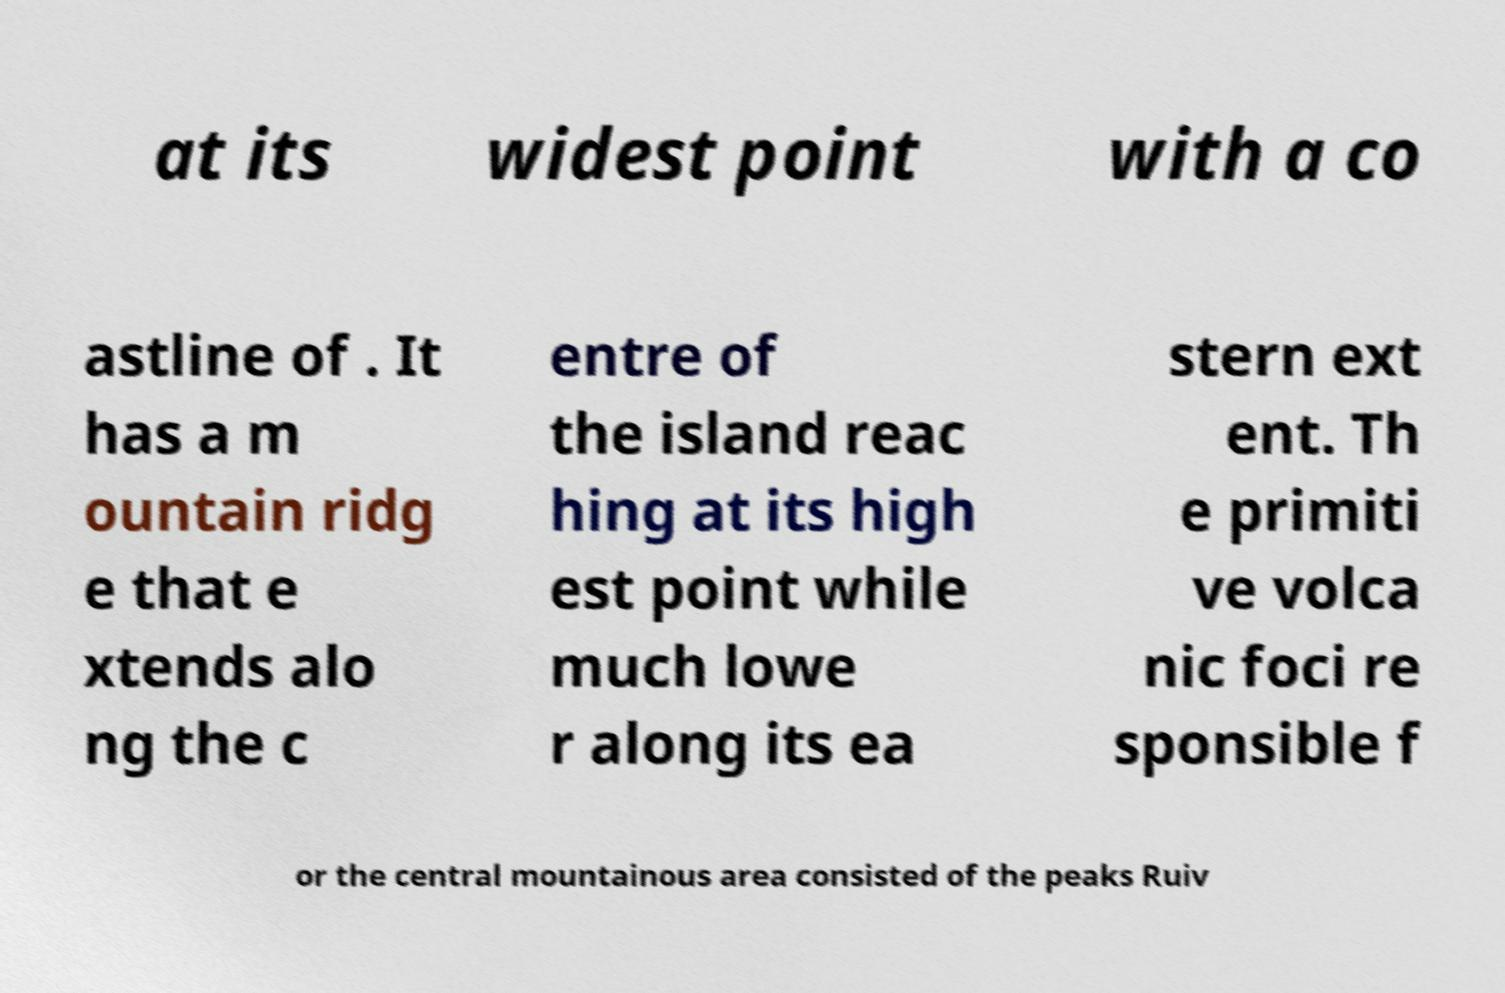Could you extract and type out the text from this image? at its widest point with a co astline of . It has a m ountain ridg e that e xtends alo ng the c entre of the island reac hing at its high est point while much lowe r along its ea stern ext ent. Th e primiti ve volca nic foci re sponsible f or the central mountainous area consisted of the peaks Ruiv 